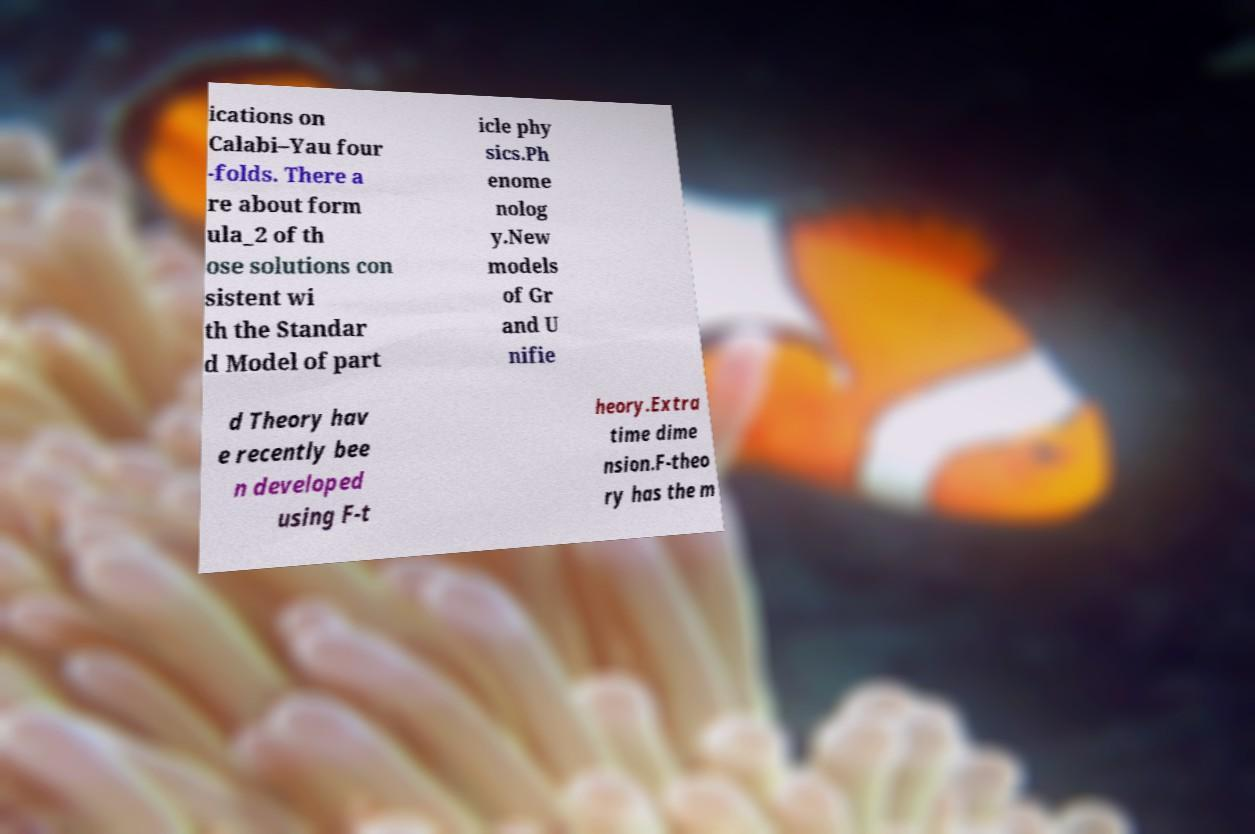There's text embedded in this image that I need extracted. Can you transcribe it verbatim? ications on Calabi–Yau four -folds. There a re about form ula_2 of th ose solutions con sistent wi th the Standar d Model of part icle phy sics.Ph enome nolog y.New models of Gr and U nifie d Theory hav e recently bee n developed using F-t heory.Extra time dime nsion.F-theo ry has the m 